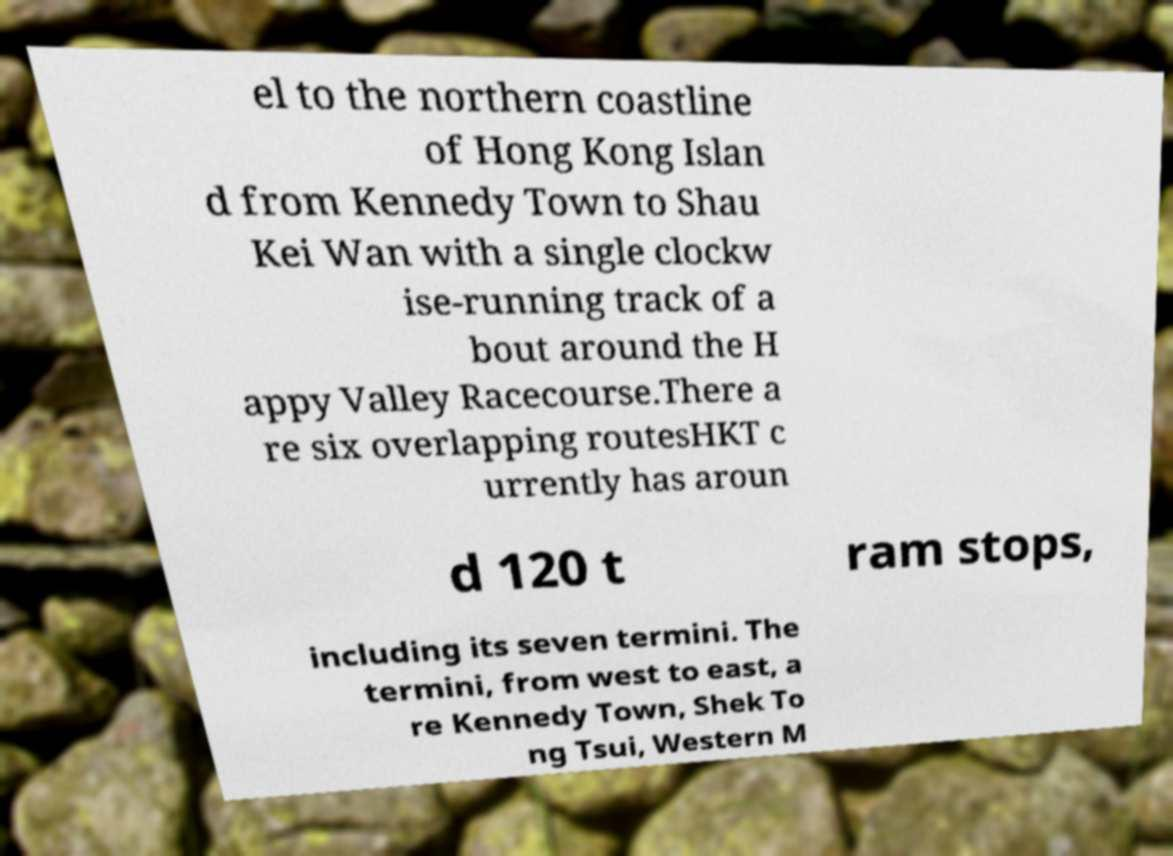There's text embedded in this image that I need extracted. Can you transcribe it verbatim? el to the northern coastline of Hong Kong Islan d from Kennedy Town to Shau Kei Wan with a single clockw ise-running track of a bout around the H appy Valley Racecourse.There a re six overlapping routesHKT c urrently has aroun d 120 t ram stops, including its seven termini. The termini, from west to east, a re Kennedy Town, Shek To ng Tsui, Western M 